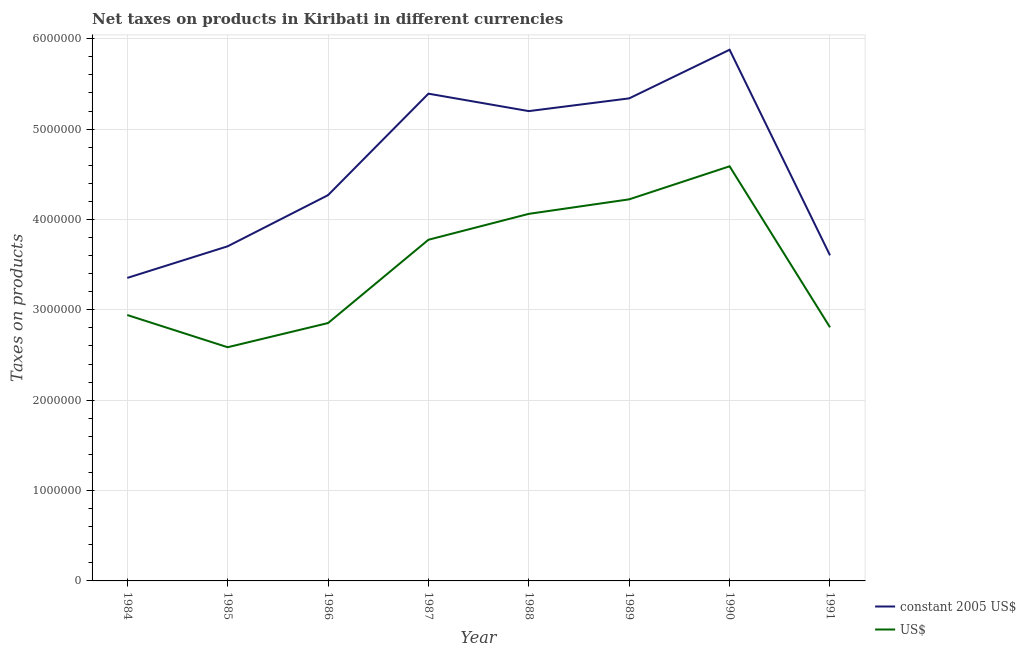Is the number of lines equal to the number of legend labels?
Offer a terse response. Yes. What is the net taxes in constant 2005 us$ in 1984?
Keep it short and to the point. 3.35e+06. Across all years, what is the maximum net taxes in constant 2005 us$?
Give a very brief answer. 5.88e+06. Across all years, what is the minimum net taxes in us$?
Offer a very short reply. 2.59e+06. In which year was the net taxes in constant 2005 us$ minimum?
Make the answer very short. 1984. What is the total net taxes in us$ in the graph?
Keep it short and to the point. 2.78e+07. What is the difference between the net taxes in us$ in 1984 and that in 1986?
Provide a succinct answer. 8.89e+04. What is the difference between the net taxes in constant 2005 us$ in 1989 and the net taxes in us$ in 1984?
Your response must be concise. 2.40e+06. What is the average net taxes in us$ per year?
Your response must be concise. 3.48e+06. In the year 1985, what is the difference between the net taxes in constant 2005 us$ and net taxes in us$?
Ensure brevity in your answer.  1.12e+06. In how many years, is the net taxes in constant 2005 us$ greater than 1400000 units?
Your answer should be compact. 8. What is the ratio of the net taxes in us$ in 1986 to that in 1991?
Your answer should be compact. 1.02. Is the net taxes in us$ in 1987 less than that in 1988?
Your answer should be very brief. Yes. What is the difference between the highest and the second highest net taxes in us$?
Keep it short and to the point. 3.66e+05. What is the difference between the highest and the lowest net taxes in us$?
Your answer should be compact. 2.00e+06. Is the net taxes in us$ strictly greater than the net taxes in constant 2005 us$ over the years?
Your answer should be compact. No. Is the net taxes in constant 2005 us$ strictly less than the net taxes in us$ over the years?
Your answer should be very brief. No. How many years are there in the graph?
Give a very brief answer. 8. What is the difference between two consecutive major ticks on the Y-axis?
Offer a very short reply. 1.00e+06. Are the values on the major ticks of Y-axis written in scientific E-notation?
Offer a very short reply. No. Does the graph contain any zero values?
Make the answer very short. No. Where does the legend appear in the graph?
Give a very brief answer. Bottom right. How many legend labels are there?
Make the answer very short. 2. How are the legend labels stacked?
Offer a terse response. Vertical. What is the title of the graph?
Your answer should be very brief. Net taxes on products in Kiribati in different currencies. Does "Quality of trade" appear as one of the legend labels in the graph?
Give a very brief answer. No. What is the label or title of the X-axis?
Make the answer very short. Year. What is the label or title of the Y-axis?
Offer a terse response. Taxes on products. What is the Taxes on products of constant 2005 US$ in 1984?
Provide a short and direct response. 3.35e+06. What is the Taxes on products in US$ in 1984?
Provide a short and direct response. 2.94e+06. What is the Taxes on products in constant 2005 US$ in 1985?
Your response must be concise. 3.70e+06. What is the Taxes on products of US$ in 1985?
Your response must be concise. 2.59e+06. What is the Taxes on products in constant 2005 US$ in 1986?
Keep it short and to the point. 4.27e+06. What is the Taxes on products of US$ in 1986?
Offer a terse response. 2.85e+06. What is the Taxes on products of constant 2005 US$ in 1987?
Make the answer very short. 5.39e+06. What is the Taxes on products of US$ in 1987?
Ensure brevity in your answer.  3.78e+06. What is the Taxes on products of constant 2005 US$ in 1988?
Keep it short and to the point. 5.20e+06. What is the Taxes on products of US$ in 1988?
Provide a short and direct response. 4.06e+06. What is the Taxes on products in constant 2005 US$ in 1989?
Offer a terse response. 5.34e+06. What is the Taxes on products in US$ in 1989?
Your answer should be very brief. 4.22e+06. What is the Taxes on products of constant 2005 US$ in 1990?
Keep it short and to the point. 5.88e+06. What is the Taxes on products of US$ in 1990?
Ensure brevity in your answer.  4.59e+06. What is the Taxes on products in constant 2005 US$ in 1991?
Your answer should be compact. 3.60e+06. What is the Taxes on products in US$ in 1991?
Keep it short and to the point. 2.81e+06. Across all years, what is the maximum Taxes on products of constant 2005 US$?
Ensure brevity in your answer.  5.88e+06. Across all years, what is the maximum Taxes on products in US$?
Your answer should be compact. 4.59e+06. Across all years, what is the minimum Taxes on products in constant 2005 US$?
Provide a succinct answer. 3.35e+06. Across all years, what is the minimum Taxes on products of US$?
Keep it short and to the point. 2.59e+06. What is the total Taxes on products of constant 2005 US$ in the graph?
Your answer should be compact. 3.67e+07. What is the total Taxes on products in US$ in the graph?
Provide a succinct answer. 2.78e+07. What is the difference between the Taxes on products in constant 2005 US$ in 1984 and that in 1985?
Give a very brief answer. -3.50e+05. What is the difference between the Taxes on products of US$ in 1984 and that in 1985?
Provide a short and direct response. 3.56e+05. What is the difference between the Taxes on products of constant 2005 US$ in 1984 and that in 1986?
Provide a short and direct response. -9.16e+05. What is the difference between the Taxes on products in US$ in 1984 and that in 1986?
Offer a very short reply. 8.89e+04. What is the difference between the Taxes on products in constant 2005 US$ in 1984 and that in 1987?
Provide a succinct answer. -2.04e+06. What is the difference between the Taxes on products in US$ in 1984 and that in 1987?
Your response must be concise. -8.33e+05. What is the difference between the Taxes on products of constant 2005 US$ in 1984 and that in 1988?
Offer a terse response. -1.85e+06. What is the difference between the Taxes on products in US$ in 1984 and that in 1988?
Offer a terse response. -1.12e+06. What is the difference between the Taxes on products in constant 2005 US$ in 1984 and that in 1989?
Provide a succinct answer. -1.99e+06. What is the difference between the Taxes on products of US$ in 1984 and that in 1989?
Provide a succinct answer. -1.28e+06. What is the difference between the Taxes on products of constant 2005 US$ in 1984 and that in 1990?
Your answer should be very brief. -2.52e+06. What is the difference between the Taxes on products of US$ in 1984 and that in 1990?
Your answer should be very brief. -1.65e+06. What is the difference between the Taxes on products in US$ in 1984 and that in 1991?
Provide a succinct answer. 1.36e+05. What is the difference between the Taxes on products in constant 2005 US$ in 1985 and that in 1986?
Ensure brevity in your answer.  -5.66e+05. What is the difference between the Taxes on products of US$ in 1985 and that in 1986?
Keep it short and to the point. -2.68e+05. What is the difference between the Taxes on products of constant 2005 US$ in 1985 and that in 1987?
Give a very brief answer. -1.69e+06. What is the difference between the Taxes on products of US$ in 1985 and that in 1987?
Offer a terse response. -1.19e+06. What is the difference between the Taxes on products of constant 2005 US$ in 1985 and that in 1988?
Make the answer very short. -1.50e+06. What is the difference between the Taxes on products of US$ in 1985 and that in 1988?
Keep it short and to the point. -1.48e+06. What is the difference between the Taxes on products of constant 2005 US$ in 1985 and that in 1989?
Make the answer very short. -1.64e+06. What is the difference between the Taxes on products of US$ in 1985 and that in 1989?
Keep it short and to the point. -1.64e+06. What is the difference between the Taxes on products in constant 2005 US$ in 1985 and that in 1990?
Provide a short and direct response. -2.18e+06. What is the difference between the Taxes on products in US$ in 1985 and that in 1990?
Ensure brevity in your answer.  -2.00e+06. What is the difference between the Taxes on products of constant 2005 US$ in 1985 and that in 1991?
Make the answer very short. 1.00e+05. What is the difference between the Taxes on products of US$ in 1985 and that in 1991?
Give a very brief answer. -2.20e+05. What is the difference between the Taxes on products of constant 2005 US$ in 1986 and that in 1987?
Offer a very short reply. -1.12e+06. What is the difference between the Taxes on products in US$ in 1986 and that in 1987?
Offer a terse response. -9.22e+05. What is the difference between the Taxes on products in constant 2005 US$ in 1986 and that in 1988?
Make the answer very short. -9.30e+05. What is the difference between the Taxes on products of US$ in 1986 and that in 1988?
Offer a very short reply. -1.21e+06. What is the difference between the Taxes on products in constant 2005 US$ in 1986 and that in 1989?
Your answer should be very brief. -1.07e+06. What is the difference between the Taxes on products in US$ in 1986 and that in 1989?
Give a very brief answer. -1.37e+06. What is the difference between the Taxes on products of constant 2005 US$ in 1986 and that in 1990?
Provide a succinct answer. -1.61e+06. What is the difference between the Taxes on products of US$ in 1986 and that in 1990?
Give a very brief answer. -1.73e+06. What is the difference between the Taxes on products in constant 2005 US$ in 1986 and that in 1991?
Provide a short and direct response. 6.66e+05. What is the difference between the Taxes on products in US$ in 1986 and that in 1991?
Your answer should be compact. 4.71e+04. What is the difference between the Taxes on products of constant 2005 US$ in 1987 and that in 1988?
Your response must be concise. 1.93e+05. What is the difference between the Taxes on products of US$ in 1987 and that in 1988?
Keep it short and to the point. -2.87e+05. What is the difference between the Taxes on products of constant 2005 US$ in 1987 and that in 1989?
Offer a very short reply. 5.20e+04. What is the difference between the Taxes on products of US$ in 1987 and that in 1989?
Provide a short and direct response. -4.47e+05. What is the difference between the Taxes on products of constant 2005 US$ in 1987 and that in 1990?
Your answer should be very brief. -4.86e+05. What is the difference between the Taxes on products in US$ in 1987 and that in 1990?
Make the answer very short. -8.13e+05. What is the difference between the Taxes on products of constant 2005 US$ in 1987 and that in 1991?
Give a very brief answer. 1.79e+06. What is the difference between the Taxes on products of US$ in 1987 and that in 1991?
Make the answer very short. 9.69e+05. What is the difference between the Taxes on products of constant 2005 US$ in 1988 and that in 1989?
Your answer should be very brief. -1.41e+05. What is the difference between the Taxes on products of US$ in 1988 and that in 1989?
Your answer should be very brief. -1.61e+05. What is the difference between the Taxes on products in constant 2005 US$ in 1988 and that in 1990?
Give a very brief answer. -6.79e+05. What is the difference between the Taxes on products of US$ in 1988 and that in 1990?
Offer a very short reply. -5.26e+05. What is the difference between the Taxes on products in constant 2005 US$ in 1988 and that in 1991?
Keep it short and to the point. 1.60e+06. What is the difference between the Taxes on products of US$ in 1988 and that in 1991?
Keep it short and to the point. 1.26e+06. What is the difference between the Taxes on products of constant 2005 US$ in 1989 and that in 1990?
Your response must be concise. -5.38e+05. What is the difference between the Taxes on products of US$ in 1989 and that in 1990?
Offer a terse response. -3.66e+05. What is the difference between the Taxes on products in constant 2005 US$ in 1989 and that in 1991?
Offer a terse response. 1.74e+06. What is the difference between the Taxes on products in US$ in 1989 and that in 1991?
Give a very brief answer. 1.42e+06. What is the difference between the Taxes on products in constant 2005 US$ in 1990 and that in 1991?
Ensure brevity in your answer.  2.28e+06. What is the difference between the Taxes on products of US$ in 1990 and that in 1991?
Give a very brief answer. 1.78e+06. What is the difference between the Taxes on products of constant 2005 US$ in 1984 and the Taxes on products of US$ in 1985?
Provide a succinct answer. 7.67e+05. What is the difference between the Taxes on products in constant 2005 US$ in 1984 and the Taxes on products in US$ in 1986?
Ensure brevity in your answer.  4.99e+05. What is the difference between the Taxes on products of constant 2005 US$ in 1984 and the Taxes on products of US$ in 1987?
Your response must be concise. -4.22e+05. What is the difference between the Taxes on products in constant 2005 US$ in 1984 and the Taxes on products in US$ in 1988?
Your response must be concise. -7.09e+05. What is the difference between the Taxes on products of constant 2005 US$ in 1984 and the Taxes on products of US$ in 1989?
Offer a very short reply. -8.70e+05. What is the difference between the Taxes on products of constant 2005 US$ in 1984 and the Taxes on products of US$ in 1990?
Ensure brevity in your answer.  -1.24e+06. What is the difference between the Taxes on products in constant 2005 US$ in 1984 and the Taxes on products in US$ in 1991?
Make the answer very short. 5.46e+05. What is the difference between the Taxes on products in constant 2005 US$ in 1985 and the Taxes on products in US$ in 1986?
Offer a terse response. 8.49e+05. What is the difference between the Taxes on products in constant 2005 US$ in 1985 and the Taxes on products in US$ in 1987?
Offer a terse response. -7.24e+04. What is the difference between the Taxes on products in constant 2005 US$ in 1985 and the Taxes on products in US$ in 1988?
Your answer should be compact. -3.59e+05. What is the difference between the Taxes on products in constant 2005 US$ in 1985 and the Taxes on products in US$ in 1989?
Keep it short and to the point. -5.20e+05. What is the difference between the Taxes on products of constant 2005 US$ in 1985 and the Taxes on products of US$ in 1990?
Give a very brief answer. -8.85e+05. What is the difference between the Taxes on products of constant 2005 US$ in 1985 and the Taxes on products of US$ in 1991?
Make the answer very short. 8.96e+05. What is the difference between the Taxes on products of constant 2005 US$ in 1986 and the Taxes on products of US$ in 1987?
Keep it short and to the point. 4.94e+05. What is the difference between the Taxes on products of constant 2005 US$ in 1986 and the Taxes on products of US$ in 1988?
Make the answer very short. 2.07e+05. What is the difference between the Taxes on products in constant 2005 US$ in 1986 and the Taxes on products in US$ in 1989?
Give a very brief answer. 4.63e+04. What is the difference between the Taxes on products in constant 2005 US$ in 1986 and the Taxes on products in US$ in 1990?
Provide a short and direct response. -3.19e+05. What is the difference between the Taxes on products of constant 2005 US$ in 1986 and the Taxes on products of US$ in 1991?
Your answer should be very brief. 1.46e+06. What is the difference between the Taxes on products in constant 2005 US$ in 1987 and the Taxes on products in US$ in 1988?
Provide a succinct answer. 1.33e+06. What is the difference between the Taxes on products in constant 2005 US$ in 1987 and the Taxes on products in US$ in 1989?
Provide a short and direct response. 1.17e+06. What is the difference between the Taxes on products of constant 2005 US$ in 1987 and the Taxes on products of US$ in 1990?
Provide a succinct answer. 8.04e+05. What is the difference between the Taxes on products in constant 2005 US$ in 1987 and the Taxes on products in US$ in 1991?
Provide a succinct answer. 2.59e+06. What is the difference between the Taxes on products in constant 2005 US$ in 1988 and the Taxes on products in US$ in 1989?
Provide a succinct answer. 9.76e+05. What is the difference between the Taxes on products of constant 2005 US$ in 1988 and the Taxes on products of US$ in 1990?
Make the answer very short. 6.11e+05. What is the difference between the Taxes on products in constant 2005 US$ in 1988 and the Taxes on products in US$ in 1991?
Give a very brief answer. 2.39e+06. What is the difference between the Taxes on products in constant 2005 US$ in 1989 and the Taxes on products in US$ in 1990?
Make the answer very short. 7.52e+05. What is the difference between the Taxes on products in constant 2005 US$ in 1989 and the Taxes on products in US$ in 1991?
Your response must be concise. 2.53e+06. What is the difference between the Taxes on products of constant 2005 US$ in 1990 and the Taxes on products of US$ in 1991?
Ensure brevity in your answer.  3.07e+06. What is the average Taxes on products in constant 2005 US$ per year?
Keep it short and to the point. 4.59e+06. What is the average Taxes on products of US$ per year?
Your answer should be very brief. 3.48e+06. In the year 1984, what is the difference between the Taxes on products in constant 2005 US$ and Taxes on products in US$?
Provide a short and direct response. 4.10e+05. In the year 1985, what is the difference between the Taxes on products of constant 2005 US$ and Taxes on products of US$?
Ensure brevity in your answer.  1.12e+06. In the year 1986, what is the difference between the Taxes on products in constant 2005 US$ and Taxes on products in US$?
Offer a very short reply. 1.42e+06. In the year 1987, what is the difference between the Taxes on products in constant 2005 US$ and Taxes on products in US$?
Provide a succinct answer. 1.62e+06. In the year 1988, what is the difference between the Taxes on products of constant 2005 US$ and Taxes on products of US$?
Your answer should be compact. 1.14e+06. In the year 1989, what is the difference between the Taxes on products in constant 2005 US$ and Taxes on products in US$?
Offer a terse response. 1.12e+06. In the year 1990, what is the difference between the Taxes on products in constant 2005 US$ and Taxes on products in US$?
Provide a short and direct response. 1.29e+06. In the year 1991, what is the difference between the Taxes on products of constant 2005 US$ and Taxes on products of US$?
Keep it short and to the point. 7.96e+05. What is the ratio of the Taxes on products of constant 2005 US$ in 1984 to that in 1985?
Give a very brief answer. 0.91. What is the ratio of the Taxes on products of US$ in 1984 to that in 1985?
Provide a short and direct response. 1.14. What is the ratio of the Taxes on products in constant 2005 US$ in 1984 to that in 1986?
Provide a succinct answer. 0.79. What is the ratio of the Taxes on products of US$ in 1984 to that in 1986?
Provide a succinct answer. 1.03. What is the ratio of the Taxes on products in constant 2005 US$ in 1984 to that in 1987?
Provide a succinct answer. 0.62. What is the ratio of the Taxes on products in US$ in 1984 to that in 1987?
Provide a short and direct response. 0.78. What is the ratio of the Taxes on products in constant 2005 US$ in 1984 to that in 1988?
Give a very brief answer. 0.64. What is the ratio of the Taxes on products in US$ in 1984 to that in 1988?
Offer a very short reply. 0.72. What is the ratio of the Taxes on products in constant 2005 US$ in 1984 to that in 1989?
Your answer should be very brief. 0.63. What is the ratio of the Taxes on products of US$ in 1984 to that in 1989?
Make the answer very short. 0.7. What is the ratio of the Taxes on products in constant 2005 US$ in 1984 to that in 1990?
Your answer should be compact. 0.57. What is the ratio of the Taxes on products of US$ in 1984 to that in 1990?
Provide a short and direct response. 0.64. What is the ratio of the Taxes on products of constant 2005 US$ in 1984 to that in 1991?
Provide a short and direct response. 0.93. What is the ratio of the Taxes on products of US$ in 1984 to that in 1991?
Provide a succinct answer. 1.05. What is the ratio of the Taxes on products of constant 2005 US$ in 1985 to that in 1986?
Your answer should be compact. 0.87. What is the ratio of the Taxes on products of US$ in 1985 to that in 1986?
Your answer should be compact. 0.91. What is the ratio of the Taxes on products in constant 2005 US$ in 1985 to that in 1987?
Your response must be concise. 0.69. What is the ratio of the Taxes on products of US$ in 1985 to that in 1987?
Give a very brief answer. 0.69. What is the ratio of the Taxes on products of constant 2005 US$ in 1985 to that in 1988?
Give a very brief answer. 0.71. What is the ratio of the Taxes on products of US$ in 1985 to that in 1988?
Your answer should be compact. 0.64. What is the ratio of the Taxes on products of constant 2005 US$ in 1985 to that in 1989?
Provide a succinct answer. 0.69. What is the ratio of the Taxes on products of US$ in 1985 to that in 1989?
Ensure brevity in your answer.  0.61. What is the ratio of the Taxes on products in constant 2005 US$ in 1985 to that in 1990?
Your answer should be compact. 0.63. What is the ratio of the Taxes on products of US$ in 1985 to that in 1990?
Your response must be concise. 0.56. What is the ratio of the Taxes on products in constant 2005 US$ in 1985 to that in 1991?
Provide a succinct answer. 1.03. What is the ratio of the Taxes on products in US$ in 1985 to that in 1991?
Your response must be concise. 0.92. What is the ratio of the Taxes on products of constant 2005 US$ in 1986 to that in 1987?
Your response must be concise. 0.79. What is the ratio of the Taxes on products of US$ in 1986 to that in 1987?
Give a very brief answer. 0.76. What is the ratio of the Taxes on products of constant 2005 US$ in 1986 to that in 1988?
Your answer should be very brief. 0.82. What is the ratio of the Taxes on products of US$ in 1986 to that in 1988?
Provide a succinct answer. 0.7. What is the ratio of the Taxes on products of constant 2005 US$ in 1986 to that in 1989?
Your answer should be compact. 0.8. What is the ratio of the Taxes on products of US$ in 1986 to that in 1989?
Provide a succinct answer. 0.68. What is the ratio of the Taxes on products in constant 2005 US$ in 1986 to that in 1990?
Provide a succinct answer. 0.73. What is the ratio of the Taxes on products in US$ in 1986 to that in 1990?
Keep it short and to the point. 0.62. What is the ratio of the Taxes on products of constant 2005 US$ in 1986 to that in 1991?
Offer a very short reply. 1.18. What is the ratio of the Taxes on products in US$ in 1986 to that in 1991?
Give a very brief answer. 1.02. What is the ratio of the Taxes on products of constant 2005 US$ in 1987 to that in 1988?
Your answer should be compact. 1.04. What is the ratio of the Taxes on products in US$ in 1987 to that in 1988?
Your response must be concise. 0.93. What is the ratio of the Taxes on products of constant 2005 US$ in 1987 to that in 1989?
Your answer should be very brief. 1.01. What is the ratio of the Taxes on products of US$ in 1987 to that in 1989?
Provide a short and direct response. 0.89. What is the ratio of the Taxes on products in constant 2005 US$ in 1987 to that in 1990?
Provide a short and direct response. 0.92. What is the ratio of the Taxes on products of US$ in 1987 to that in 1990?
Provide a succinct answer. 0.82. What is the ratio of the Taxes on products of constant 2005 US$ in 1987 to that in 1991?
Your response must be concise. 1.5. What is the ratio of the Taxes on products of US$ in 1987 to that in 1991?
Give a very brief answer. 1.35. What is the ratio of the Taxes on products of constant 2005 US$ in 1988 to that in 1989?
Offer a terse response. 0.97. What is the ratio of the Taxes on products in constant 2005 US$ in 1988 to that in 1990?
Your answer should be compact. 0.88. What is the ratio of the Taxes on products in US$ in 1988 to that in 1990?
Your answer should be very brief. 0.89. What is the ratio of the Taxes on products in constant 2005 US$ in 1988 to that in 1991?
Offer a very short reply. 1.44. What is the ratio of the Taxes on products in US$ in 1988 to that in 1991?
Keep it short and to the point. 1.45. What is the ratio of the Taxes on products in constant 2005 US$ in 1989 to that in 1990?
Offer a very short reply. 0.91. What is the ratio of the Taxes on products in US$ in 1989 to that in 1990?
Provide a short and direct response. 0.92. What is the ratio of the Taxes on products of constant 2005 US$ in 1989 to that in 1991?
Provide a short and direct response. 1.48. What is the ratio of the Taxes on products of US$ in 1989 to that in 1991?
Provide a succinct answer. 1.5. What is the ratio of the Taxes on products of constant 2005 US$ in 1990 to that in 1991?
Your answer should be compact. 1.63. What is the ratio of the Taxes on products in US$ in 1990 to that in 1991?
Your answer should be very brief. 1.63. What is the difference between the highest and the second highest Taxes on products of constant 2005 US$?
Your response must be concise. 4.86e+05. What is the difference between the highest and the second highest Taxes on products in US$?
Your answer should be compact. 3.66e+05. What is the difference between the highest and the lowest Taxes on products in constant 2005 US$?
Your answer should be compact. 2.52e+06. What is the difference between the highest and the lowest Taxes on products in US$?
Provide a succinct answer. 2.00e+06. 